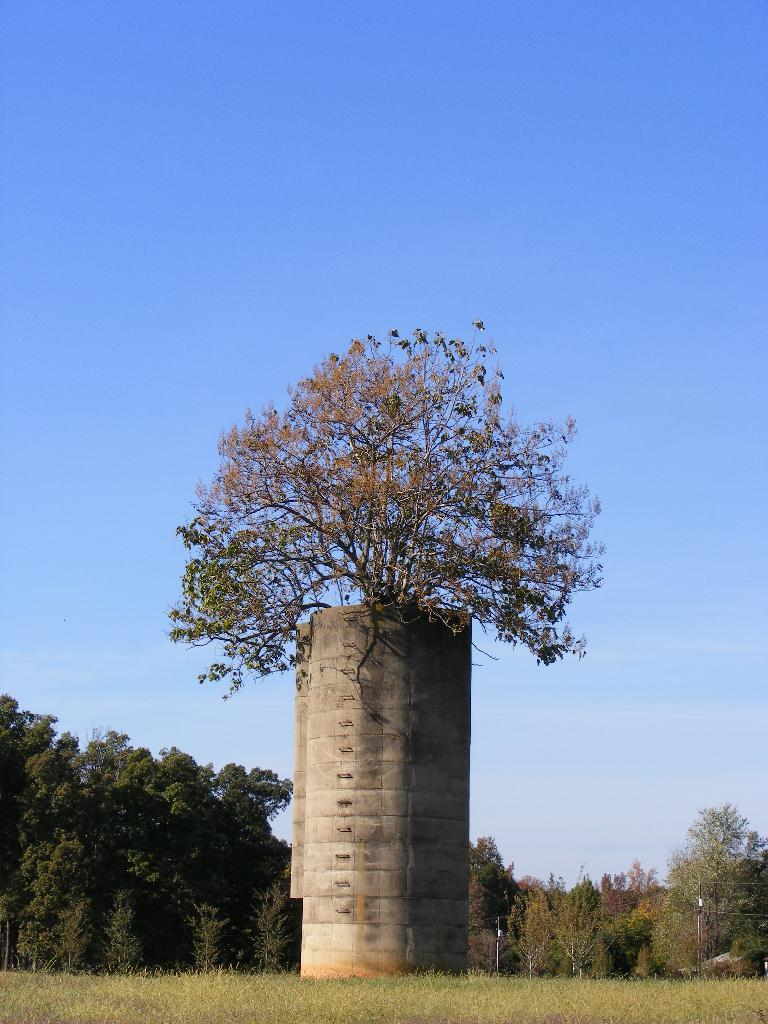What is the main structure in the image? There is a tower in the image. What is growing on the tower? Trees are present on the tower. Where is the tower located? The tower is on the grass. What can be seen in the background of the image? There are trees in the background of the image. How would you describe the sky in the image? The sky is blue with clouds. What type of engine is powering the tower in the image? There is no engine present in the image, as the tower is not a vehicle or machine that requires an engine for operation. 